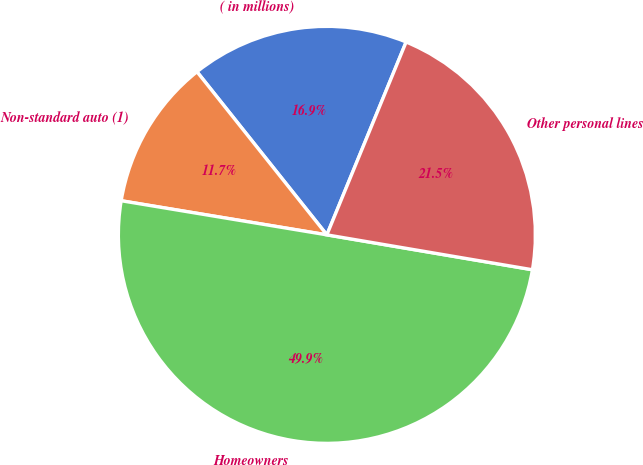<chart> <loc_0><loc_0><loc_500><loc_500><pie_chart><fcel>( in millions)<fcel>Non-standard auto (1)<fcel>Homeowners<fcel>Other personal lines<nl><fcel>16.91%<fcel>11.68%<fcel>49.94%<fcel>21.47%<nl></chart> 